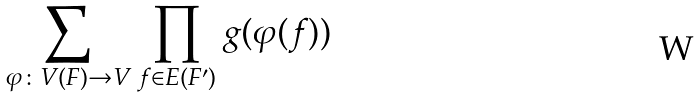<formula> <loc_0><loc_0><loc_500><loc_500>\sum _ { \varphi \colon V ( F ) \to V } \prod _ { f \in E ( F ^ { \prime } ) } g ( \varphi ( f ) )</formula> 